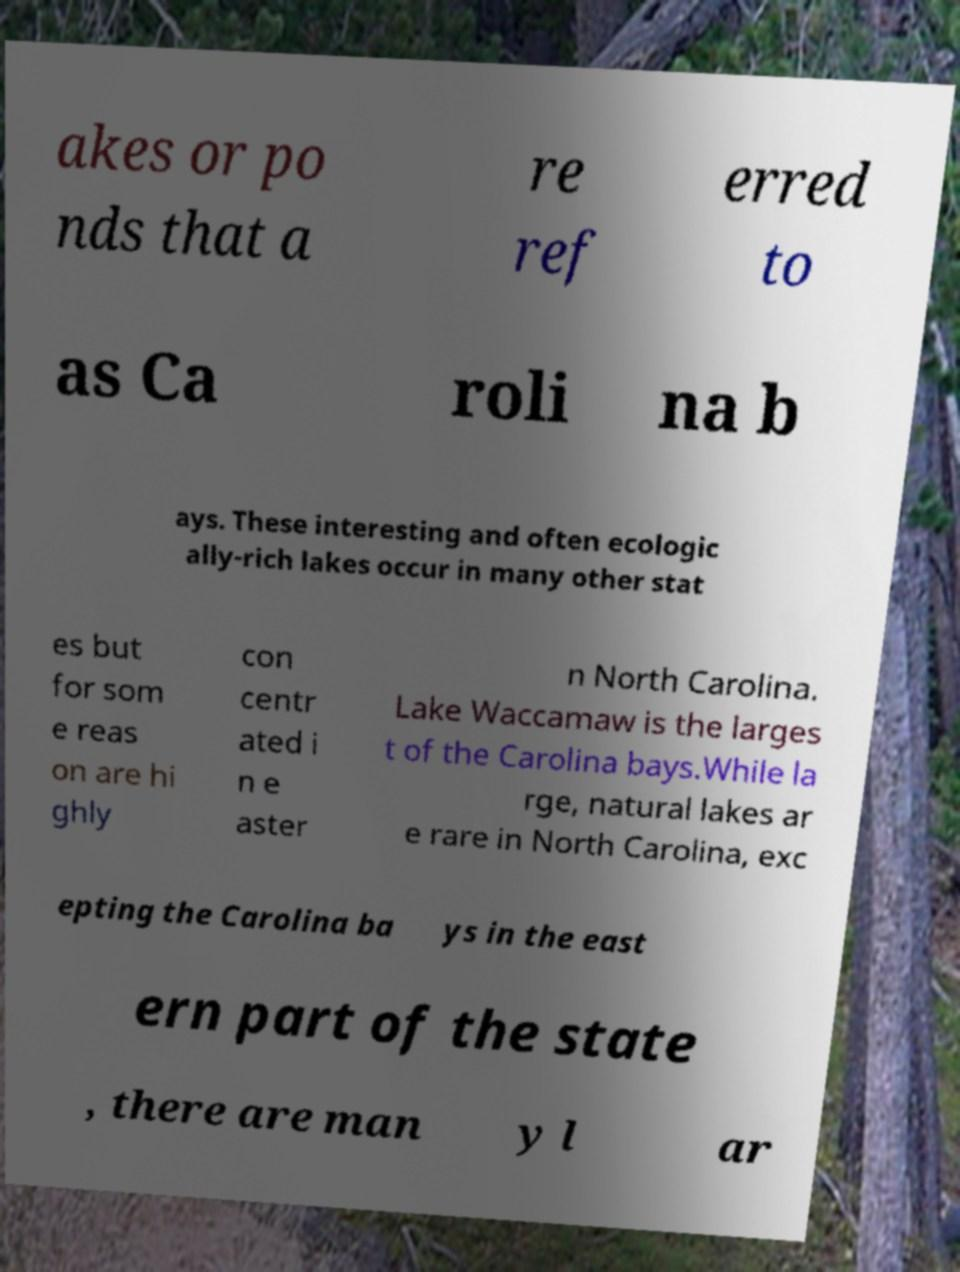Could you assist in decoding the text presented in this image and type it out clearly? akes or po nds that a re ref erred to as Ca roli na b ays. These interesting and often ecologic ally-rich lakes occur in many other stat es but for som e reas on are hi ghly con centr ated i n e aster n North Carolina. Lake Waccamaw is the larges t of the Carolina bays.While la rge, natural lakes ar e rare in North Carolina, exc epting the Carolina ba ys in the east ern part of the state , there are man y l ar 